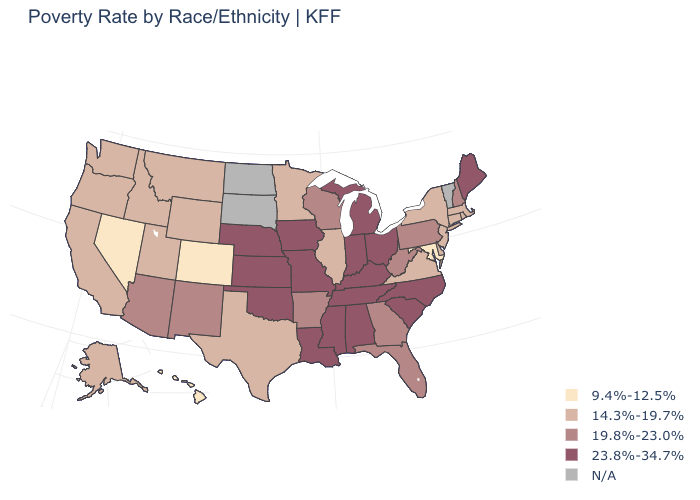Does the map have missing data?
Short answer required. Yes. What is the value of Maine?
Quick response, please. 23.8%-34.7%. What is the value of South Carolina?
Concise answer only. 23.8%-34.7%. What is the highest value in the West ?
Be succinct. 19.8%-23.0%. Name the states that have a value in the range N/A?
Answer briefly. North Dakota, South Dakota, Vermont. Does Oklahoma have the highest value in the South?
Keep it brief. Yes. Name the states that have a value in the range N/A?
Short answer required. North Dakota, South Dakota, Vermont. Is the legend a continuous bar?
Quick response, please. No. What is the value of Kentucky?
Short answer required. 23.8%-34.7%. What is the value of Louisiana?
Answer briefly. 23.8%-34.7%. Name the states that have a value in the range 23.8%-34.7%?
Concise answer only. Alabama, Indiana, Iowa, Kansas, Kentucky, Louisiana, Maine, Michigan, Mississippi, Missouri, Nebraska, North Carolina, Ohio, Oklahoma, South Carolina, Tennessee. Does Nevada have the lowest value in the USA?
Short answer required. Yes. Among the states that border Ohio , which have the lowest value?
Answer briefly. Pennsylvania, West Virginia. 